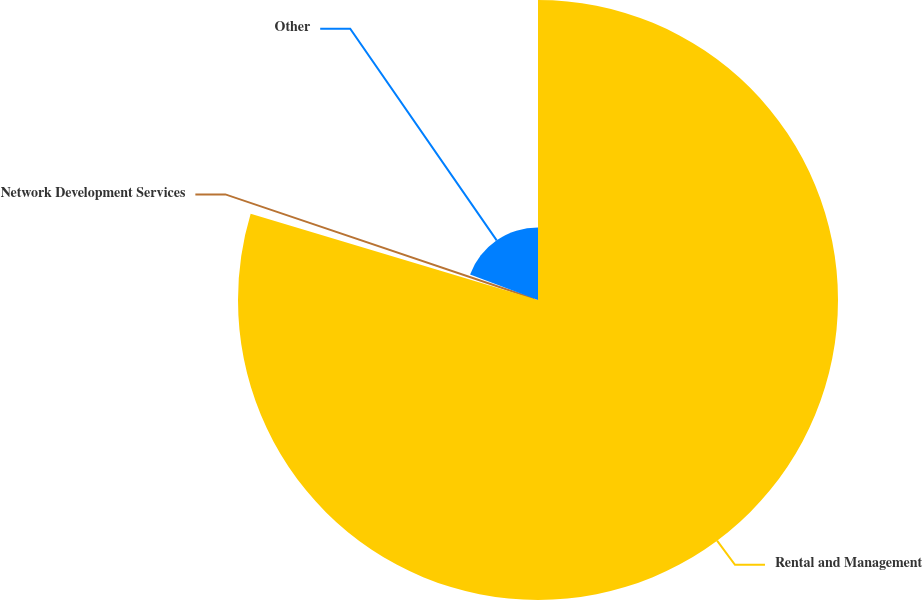Convert chart. <chart><loc_0><loc_0><loc_500><loc_500><pie_chart><fcel>Rental and Management<fcel>Network Development Services<fcel>Other<nl><fcel>79.64%<fcel>1.09%<fcel>19.27%<nl></chart> 